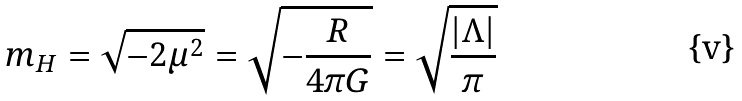<formula> <loc_0><loc_0><loc_500><loc_500>m _ { H } = \sqrt { - 2 \mu ^ { 2 } } = \sqrt { - \frac { R } { 4 \pi G } } = \sqrt { \frac { \left | \Lambda \right | } { \pi } }</formula> 